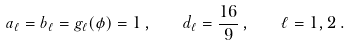Convert formula to latex. <formula><loc_0><loc_0><loc_500><loc_500>a _ { \ell } = b _ { \ell } = g _ { \ell } ( \phi ) = 1 \, , \quad d _ { \ell } = \frac { 1 6 } { 9 } \, , \quad \ell = 1 , 2 \, .</formula> 